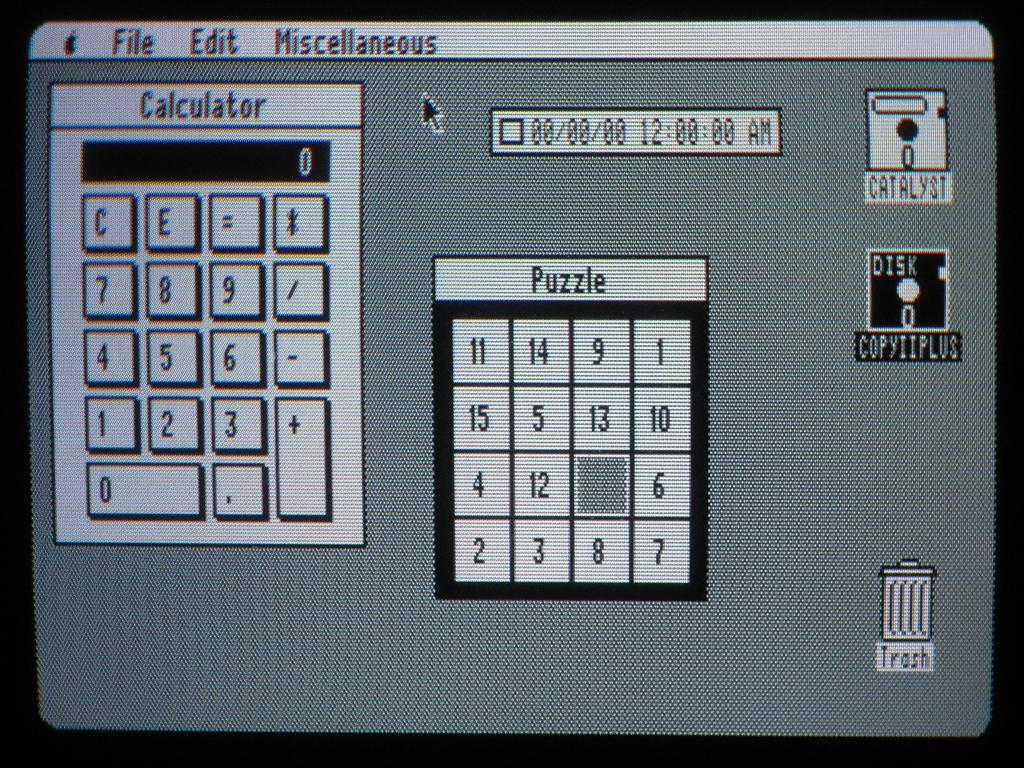Provide a one-sentence caption for the provided image. A computer screen with a calculator and puzzle displayed with the desktop. 